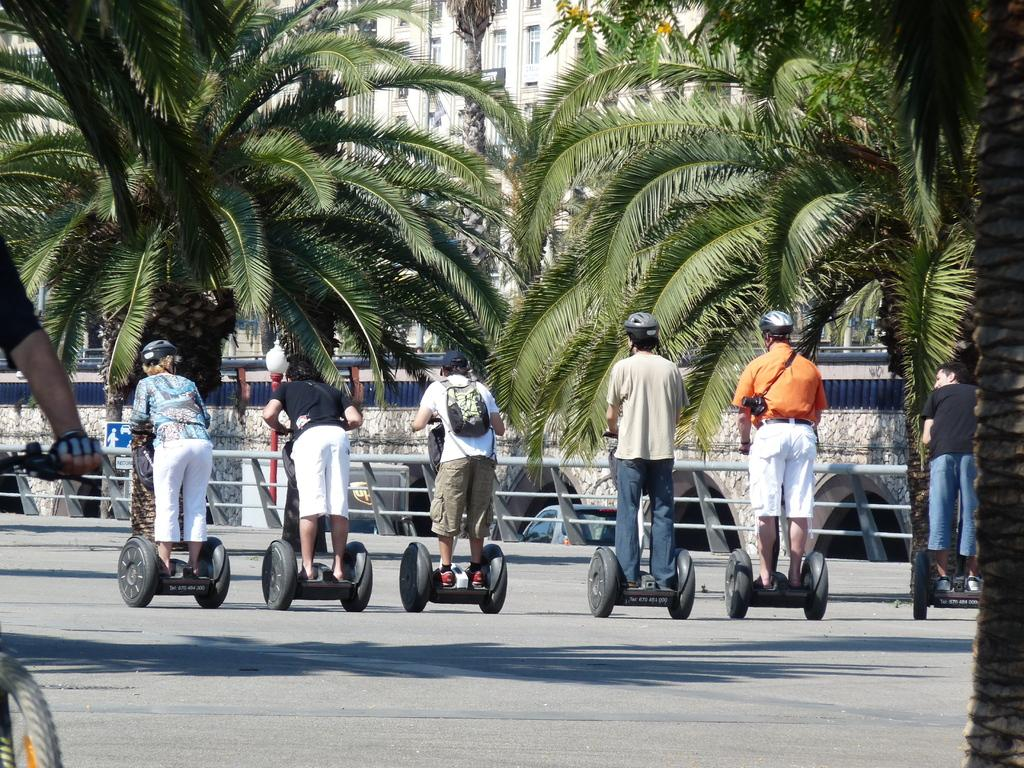What are the persons in the image doing? The persons in the image are standing on open wheel cars. What safety equipment are the persons wearing? The persons are wearing helmets. What can be seen in the background of the image? There are coconut trees, buildings, a road, a grill, and flowers visible in the background. What type of prison can be seen in the image? There is no prison present in the image. Is the coast visible in the image? The image does not depict a coastline or any coastal features. 